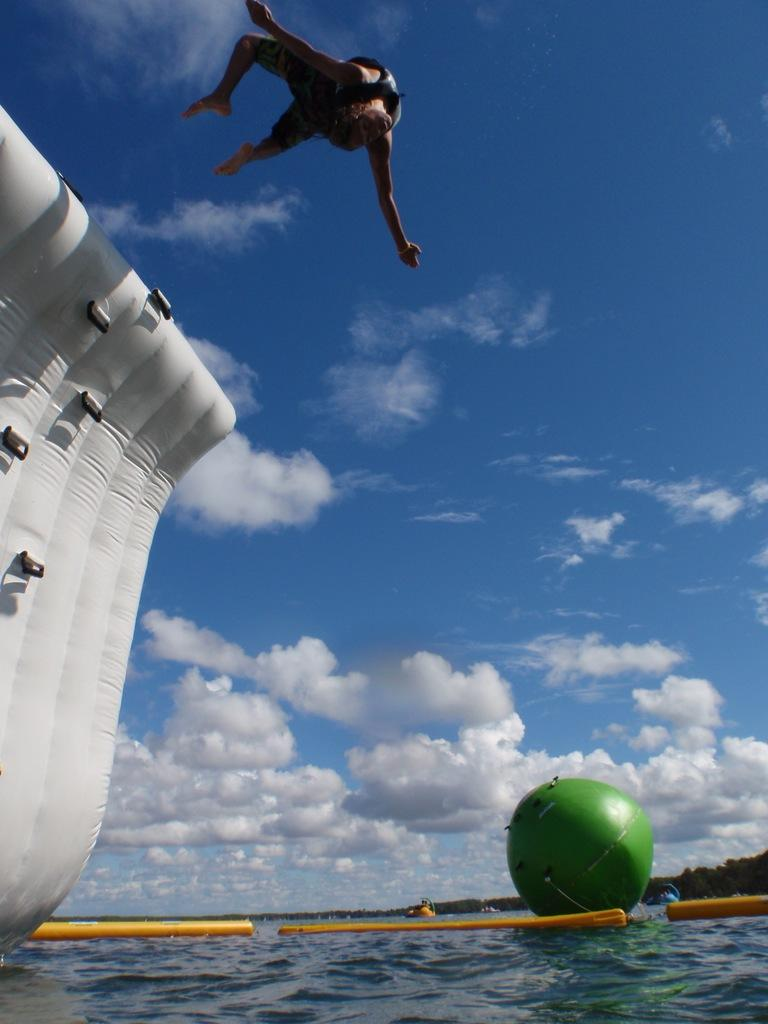What is present in the image that is related to water? There is water in the image. What type of object can be seen floating in the water? There is an inflatable object in the image. What can be seen in the sky in the image? There are clouds visible in the sky. Who is present in the image? There is a man in the image. What type of bucket is being used to control the water in the image? There is no bucket present in the image, and therefore no control over the water is depicted. What type of relation does the man have with the inflatable object in the image? The provided facts do not indicate any specific relation between the man and the inflatable object. 